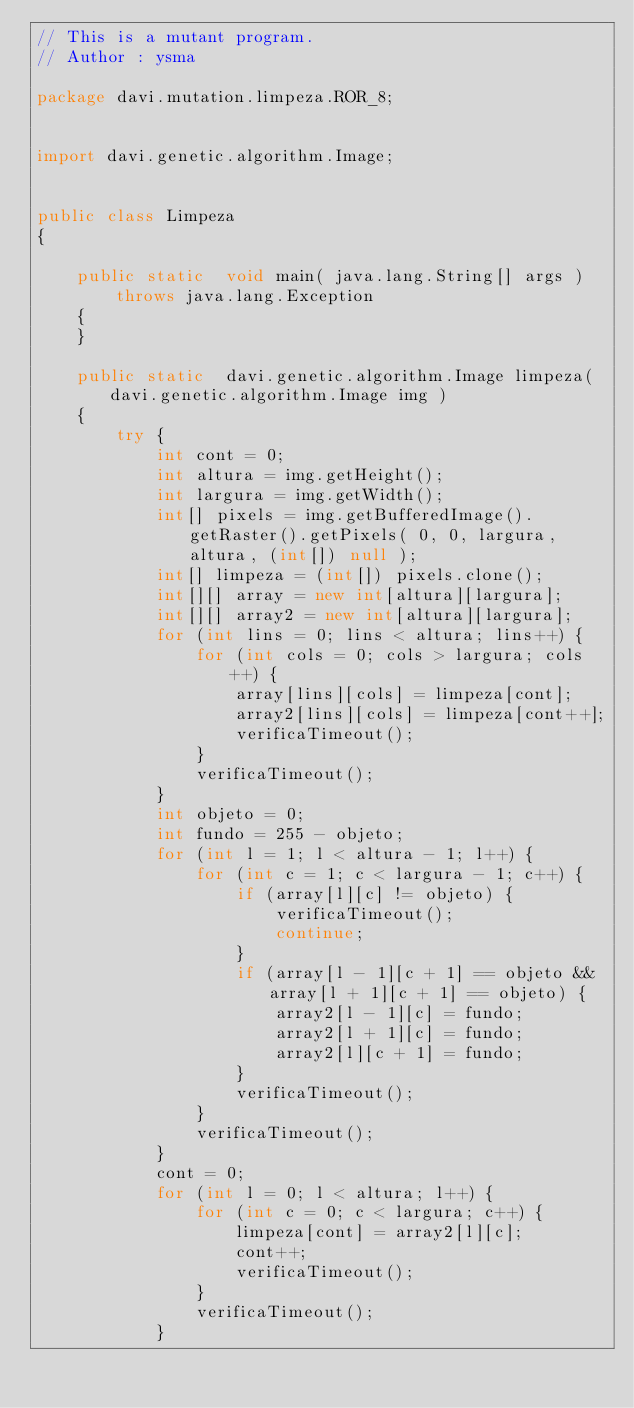<code> <loc_0><loc_0><loc_500><loc_500><_Java_>// This is a mutant program.
// Author : ysma

package davi.mutation.limpeza.ROR_8;


import davi.genetic.algorithm.Image;


public class Limpeza
{

    public static  void main( java.lang.String[] args )
        throws java.lang.Exception
    {
    }

    public static  davi.genetic.algorithm.Image limpeza( davi.genetic.algorithm.Image img )
    {
        try {
            int cont = 0;
            int altura = img.getHeight();
            int largura = img.getWidth();
            int[] pixels = img.getBufferedImage().getRaster().getPixels( 0, 0, largura, altura, (int[]) null );
            int[] limpeza = (int[]) pixels.clone();
            int[][] array = new int[altura][largura];
            int[][] array2 = new int[altura][largura];
            for (int lins = 0; lins < altura; lins++) {
                for (int cols = 0; cols > largura; cols++) {
                    array[lins][cols] = limpeza[cont];
                    array2[lins][cols] = limpeza[cont++];
                    verificaTimeout();
                }
                verificaTimeout();
            }
            int objeto = 0;
            int fundo = 255 - objeto;
            for (int l = 1; l < altura - 1; l++) {
                for (int c = 1; c < largura - 1; c++) {
                    if (array[l][c] != objeto) {
                        verificaTimeout();
                        continue;
                    }
                    if (array[l - 1][c + 1] == objeto && array[l + 1][c + 1] == objeto) {
                        array2[l - 1][c] = fundo;
                        array2[l + 1][c] = fundo;
                        array2[l][c + 1] = fundo;
                    }
                    verificaTimeout();
                }
                verificaTimeout();
            }
            cont = 0;
            for (int l = 0; l < altura; l++) {
                for (int c = 0; c < largura; c++) {
                    limpeza[cont] = array2[l][c];
                    cont++;
                    verificaTimeout();
                }
                verificaTimeout();
            }</code> 